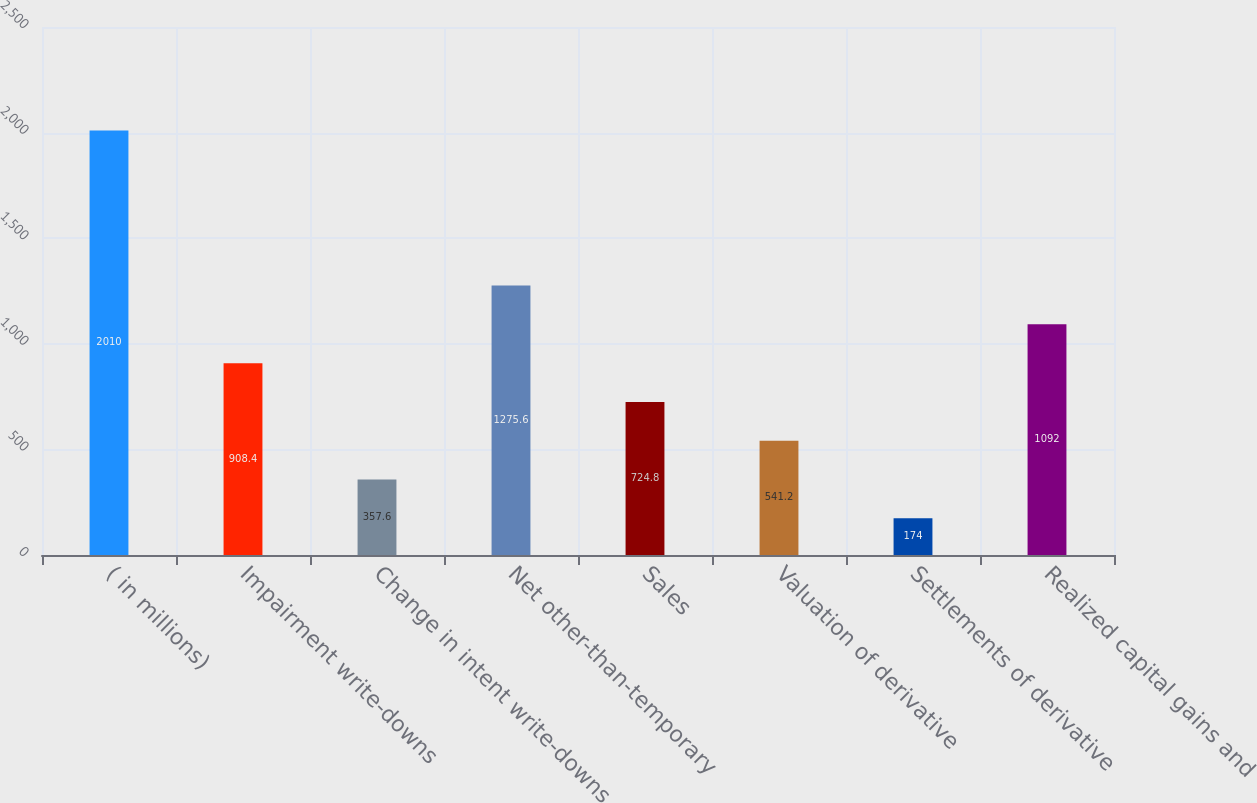<chart> <loc_0><loc_0><loc_500><loc_500><bar_chart><fcel>( in millions)<fcel>Impairment write-downs<fcel>Change in intent write-downs<fcel>Net other-than-temporary<fcel>Sales<fcel>Valuation of derivative<fcel>Settlements of derivative<fcel>Realized capital gains and<nl><fcel>2010<fcel>908.4<fcel>357.6<fcel>1275.6<fcel>724.8<fcel>541.2<fcel>174<fcel>1092<nl></chart> 